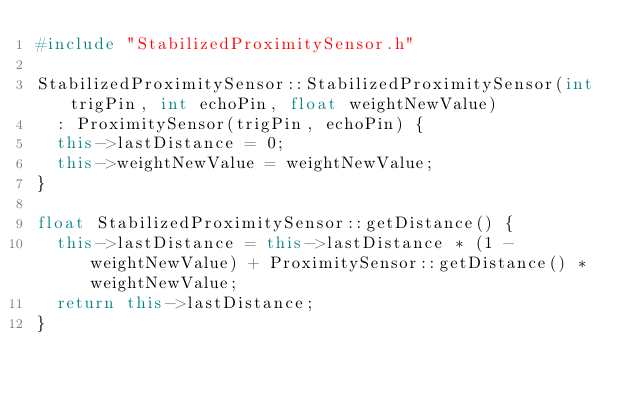Convert code to text. <code><loc_0><loc_0><loc_500><loc_500><_C++_>#include "StabilizedProximitySensor.h"

StabilizedProximitySensor::StabilizedProximitySensor(int trigPin, int echoPin, float weightNewValue)
  : ProximitySensor(trigPin, echoPin) {
  this->lastDistance = 0;
  this->weightNewValue = weightNewValue;
}

float StabilizedProximitySensor::getDistance() {
  this->lastDistance = this->lastDistance * (1 - weightNewValue) + ProximitySensor::getDistance() * weightNewValue;
  return this->lastDistance;
}
</code> 